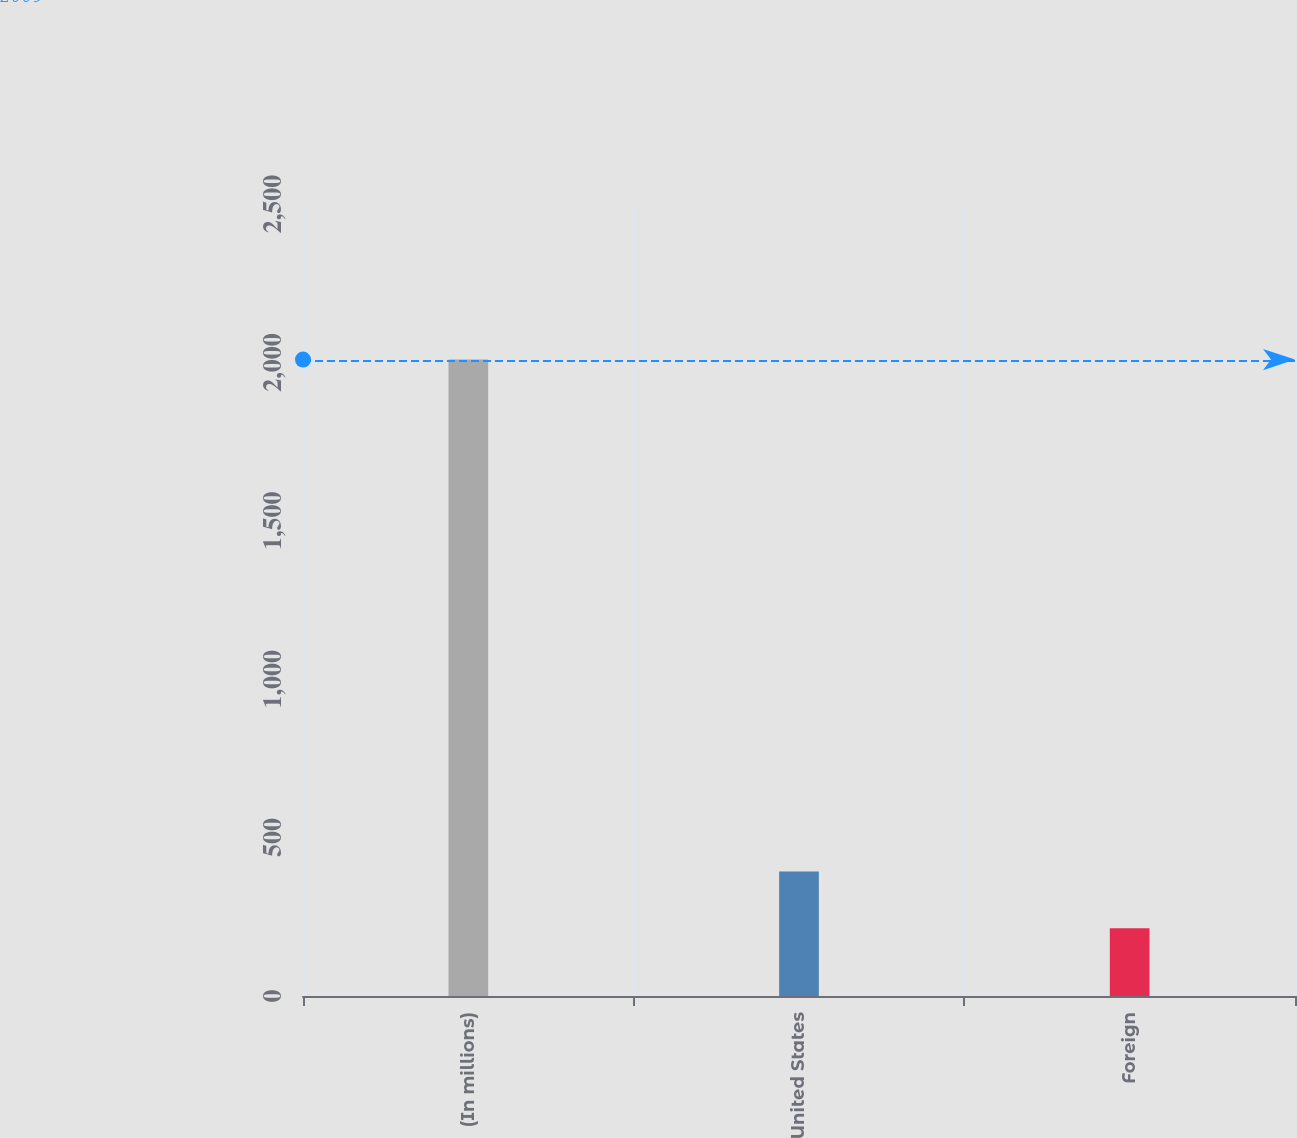Convert chart. <chart><loc_0><loc_0><loc_500><loc_500><bar_chart><fcel>(In millions)<fcel>United States<fcel>Foreign<nl><fcel>2009<fcel>393.14<fcel>213.6<nl></chart> 